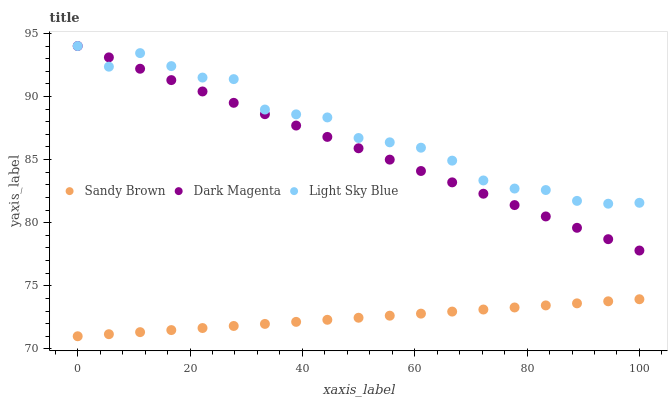Does Sandy Brown have the minimum area under the curve?
Answer yes or no. Yes. Does Light Sky Blue have the maximum area under the curve?
Answer yes or no. Yes. Does Dark Magenta have the minimum area under the curve?
Answer yes or no. No. Does Dark Magenta have the maximum area under the curve?
Answer yes or no. No. Is Dark Magenta the smoothest?
Answer yes or no. Yes. Is Light Sky Blue the roughest?
Answer yes or no. Yes. Is Sandy Brown the smoothest?
Answer yes or no. No. Is Sandy Brown the roughest?
Answer yes or no. No. Does Sandy Brown have the lowest value?
Answer yes or no. Yes. Does Dark Magenta have the lowest value?
Answer yes or no. No. Does Dark Magenta have the highest value?
Answer yes or no. Yes. Does Sandy Brown have the highest value?
Answer yes or no. No. Is Sandy Brown less than Light Sky Blue?
Answer yes or no. Yes. Is Dark Magenta greater than Sandy Brown?
Answer yes or no. Yes. Does Light Sky Blue intersect Dark Magenta?
Answer yes or no. Yes. Is Light Sky Blue less than Dark Magenta?
Answer yes or no. No. Is Light Sky Blue greater than Dark Magenta?
Answer yes or no. No. Does Sandy Brown intersect Light Sky Blue?
Answer yes or no. No. 